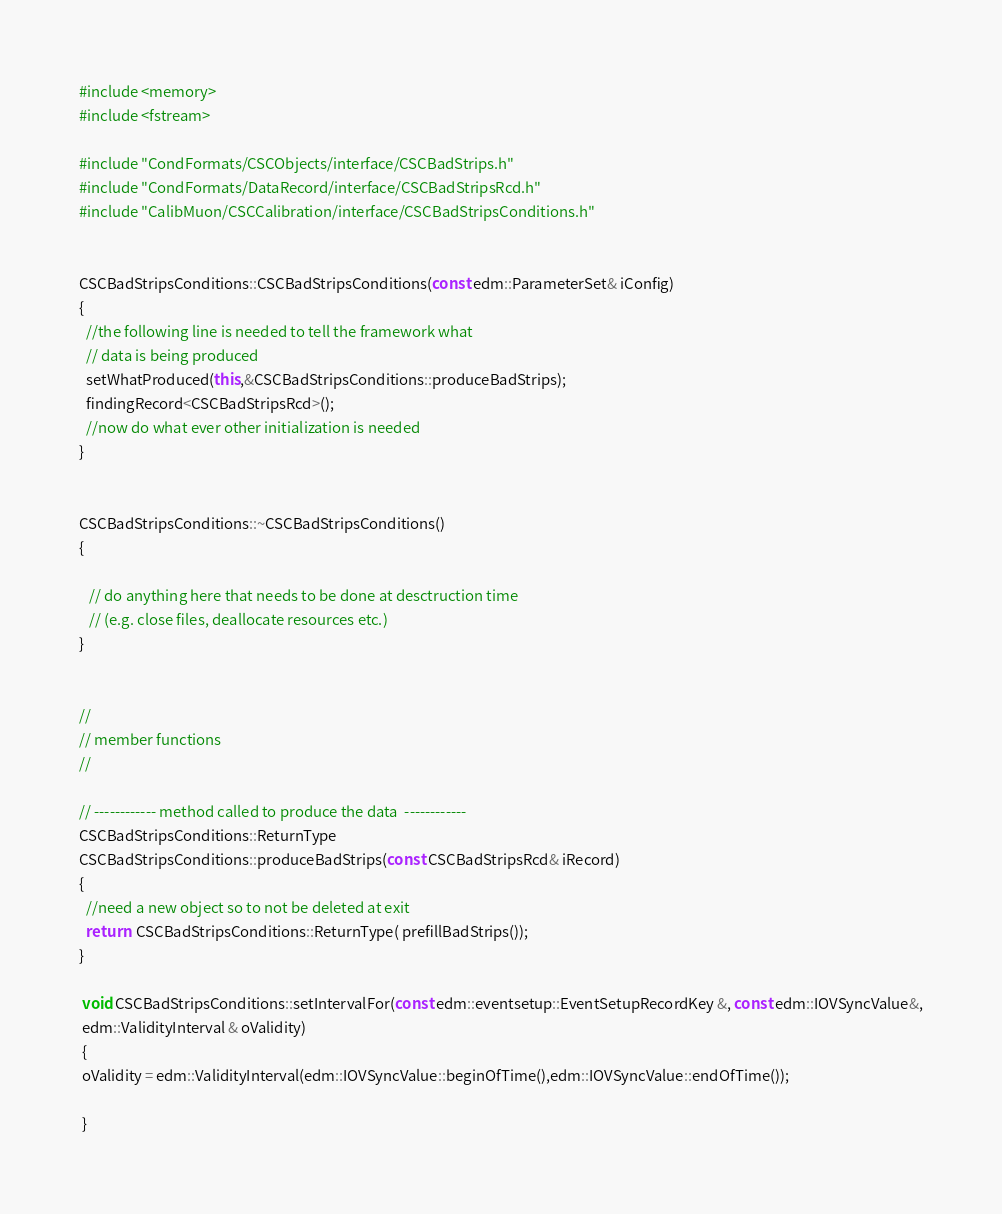<code> <loc_0><loc_0><loc_500><loc_500><_C++_>#include <memory>
#include <fstream>

#include "CondFormats/CSCObjects/interface/CSCBadStrips.h"
#include "CondFormats/DataRecord/interface/CSCBadStripsRcd.h"
#include "CalibMuon/CSCCalibration/interface/CSCBadStripsConditions.h"


CSCBadStripsConditions::CSCBadStripsConditions(const edm::ParameterSet& iConfig)
{
  //the following line is needed to tell the framework what
  // data is being produced
  setWhatProduced(this,&CSCBadStripsConditions::produceBadStrips);
  findingRecord<CSCBadStripsRcd>();
  //now do what ever other initialization is needed
}


CSCBadStripsConditions::~CSCBadStripsConditions()
{
 
   // do anything here that needs to be done at desctruction time
   // (e.g. close files, deallocate resources etc.)
}


//
// member functions
//

// ------------ method called to produce the data  ------------
CSCBadStripsConditions::ReturnType
CSCBadStripsConditions::produceBadStrips(const CSCBadStripsRcd& iRecord)
{
  //need a new object so to not be deleted at exit
  return  CSCBadStripsConditions::ReturnType( prefillBadStrips());
}

 void CSCBadStripsConditions::setIntervalFor(const edm::eventsetup::EventSetupRecordKey &, const edm::IOVSyncValue&,
 edm::ValidityInterval & oValidity)
 {
 oValidity = edm::ValidityInterval(edm::IOVSyncValue::beginOfTime(),edm::IOVSyncValue::endOfTime());
 
 }
</code> 